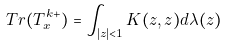<formula> <loc_0><loc_0><loc_500><loc_500>T r ( T ^ { k + } _ { x } ) = \int _ { | z | < 1 } K ( z , z ) d \lambda ( z )</formula> 